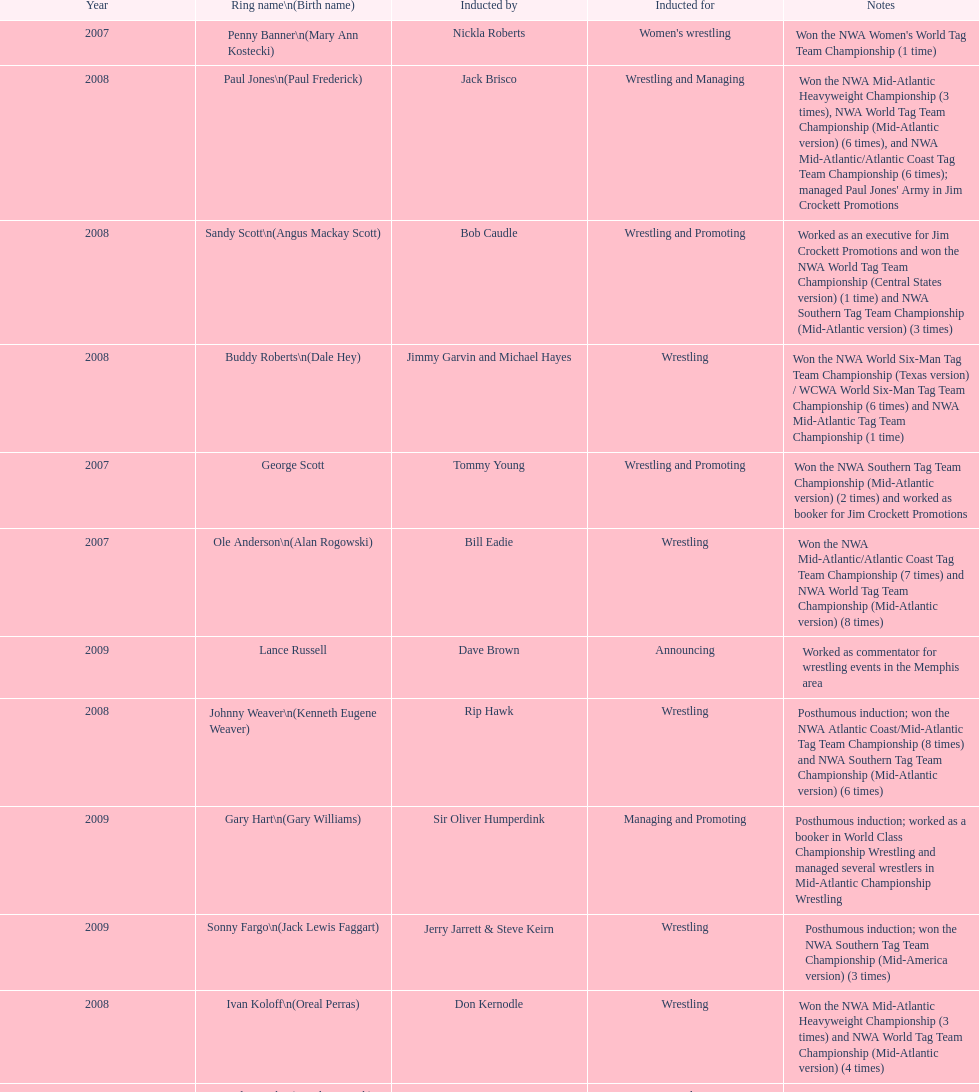Who was the only person to be inducted for wrestling and managing? Paul Jones. 